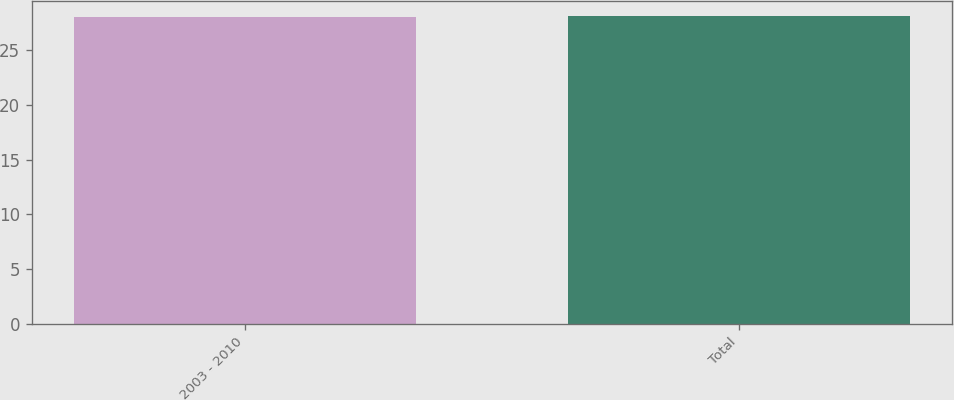Convert chart to OTSL. <chart><loc_0><loc_0><loc_500><loc_500><bar_chart><fcel>2003 - 2010<fcel>Total<nl><fcel>28<fcel>28.1<nl></chart> 